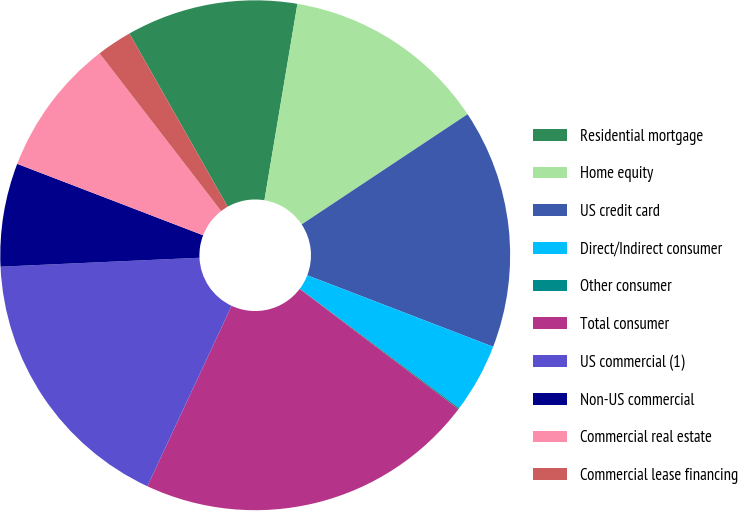Convert chart to OTSL. <chart><loc_0><loc_0><loc_500><loc_500><pie_chart><fcel>Residential mortgage<fcel>Home equity<fcel>US credit card<fcel>Direct/Indirect consumer<fcel>Other consumer<fcel>Total consumer<fcel>US commercial (1)<fcel>Non-US commercial<fcel>Commercial real estate<fcel>Commercial lease financing<nl><fcel>10.86%<fcel>13.02%<fcel>15.17%<fcel>4.39%<fcel>0.08%<fcel>21.64%<fcel>17.33%<fcel>6.55%<fcel>8.71%<fcel>2.24%<nl></chart> 